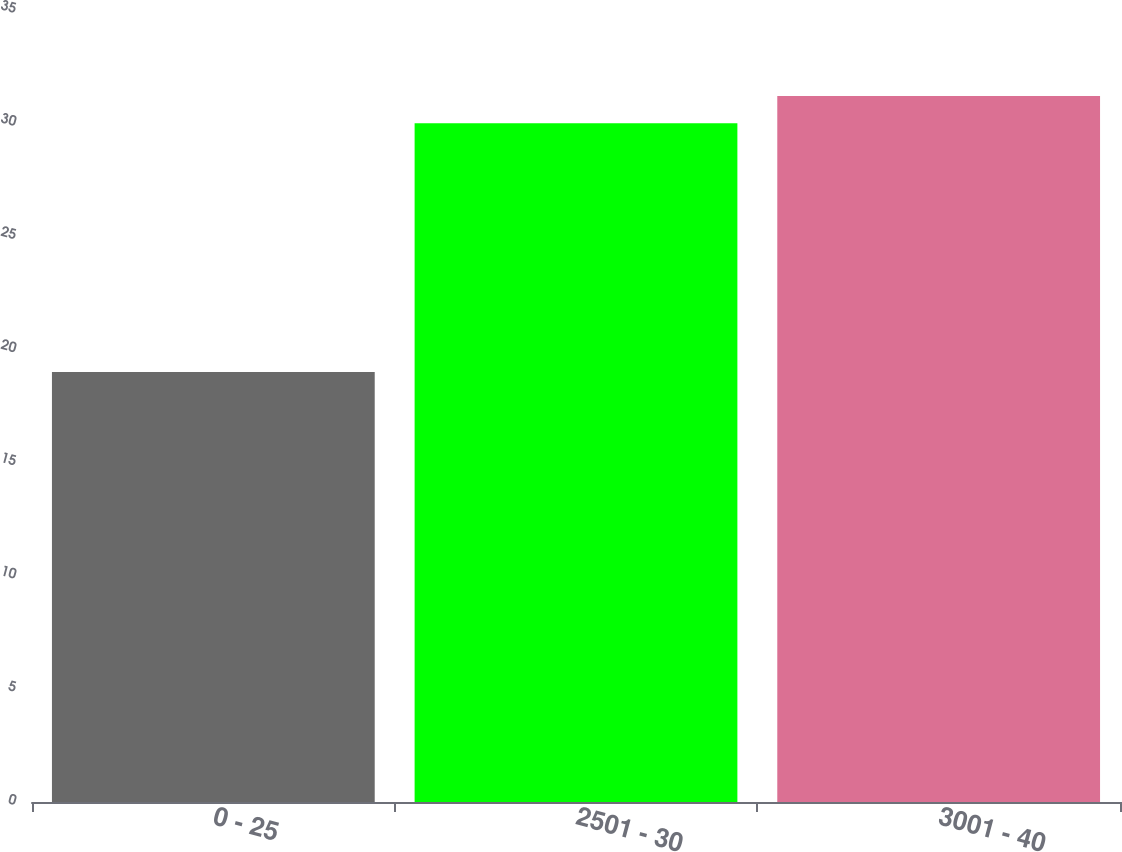<chart> <loc_0><loc_0><loc_500><loc_500><bar_chart><fcel>0 - 25<fcel>2501 - 30<fcel>3001 - 40<nl><fcel>19<fcel>30<fcel>31.2<nl></chart> 